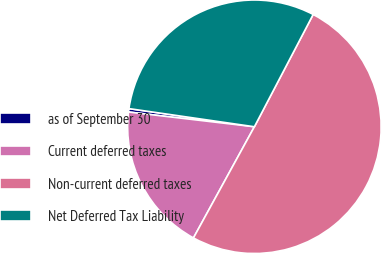Convert chart. <chart><loc_0><loc_0><loc_500><loc_500><pie_chart><fcel>as of September 30<fcel>Current deferred taxes<fcel>Non-current deferred taxes<fcel>Net Deferred Tax Liability<nl><fcel>0.43%<fcel>18.88%<fcel>50.31%<fcel>30.39%<nl></chart> 